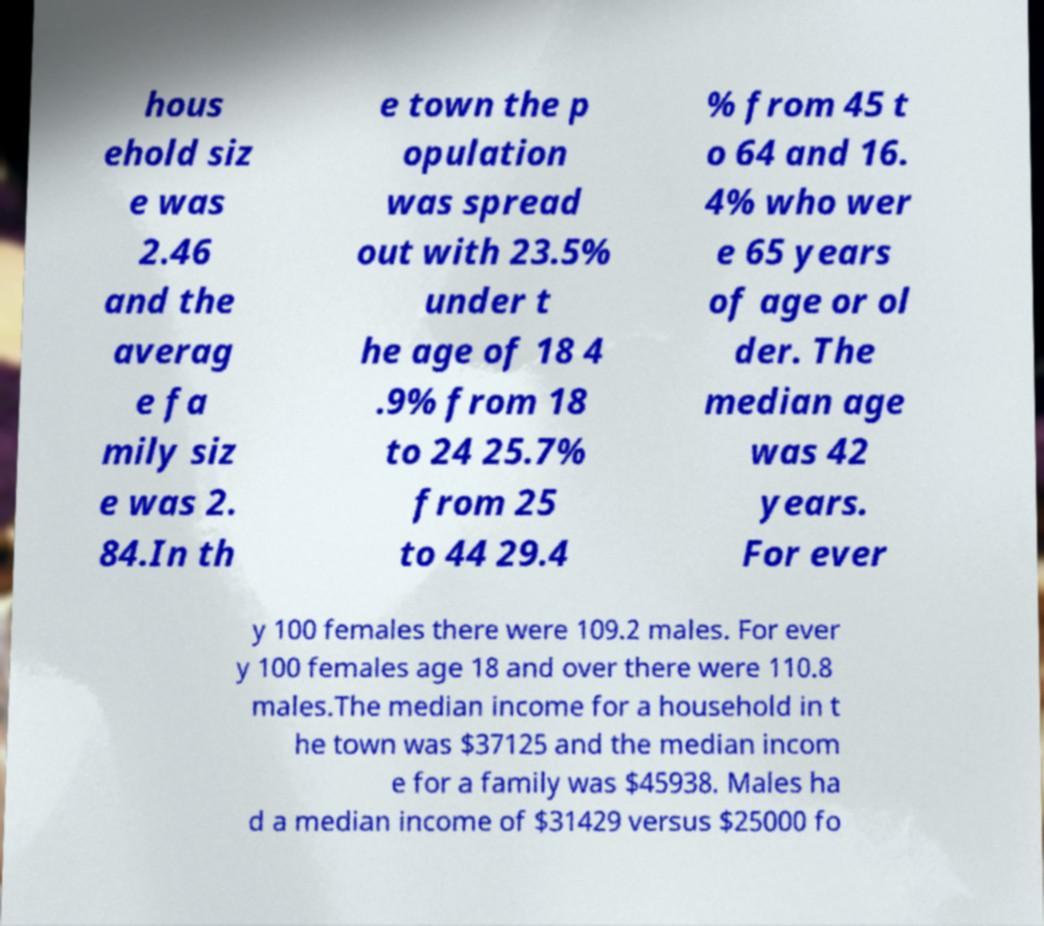Can you accurately transcribe the text from the provided image for me? hous ehold siz e was 2.46 and the averag e fa mily siz e was 2. 84.In th e town the p opulation was spread out with 23.5% under t he age of 18 4 .9% from 18 to 24 25.7% from 25 to 44 29.4 % from 45 t o 64 and 16. 4% who wer e 65 years of age or ol der. The median age was 42 years. For ever y 100 females there were 109.2 males. For ever y 100 females age 18 and over there were 110.8 males.The median income for a household in t he town was $37125 and the median incom e for a family was $45938. Males ha d a median income of $31429 versus $25000 fo 